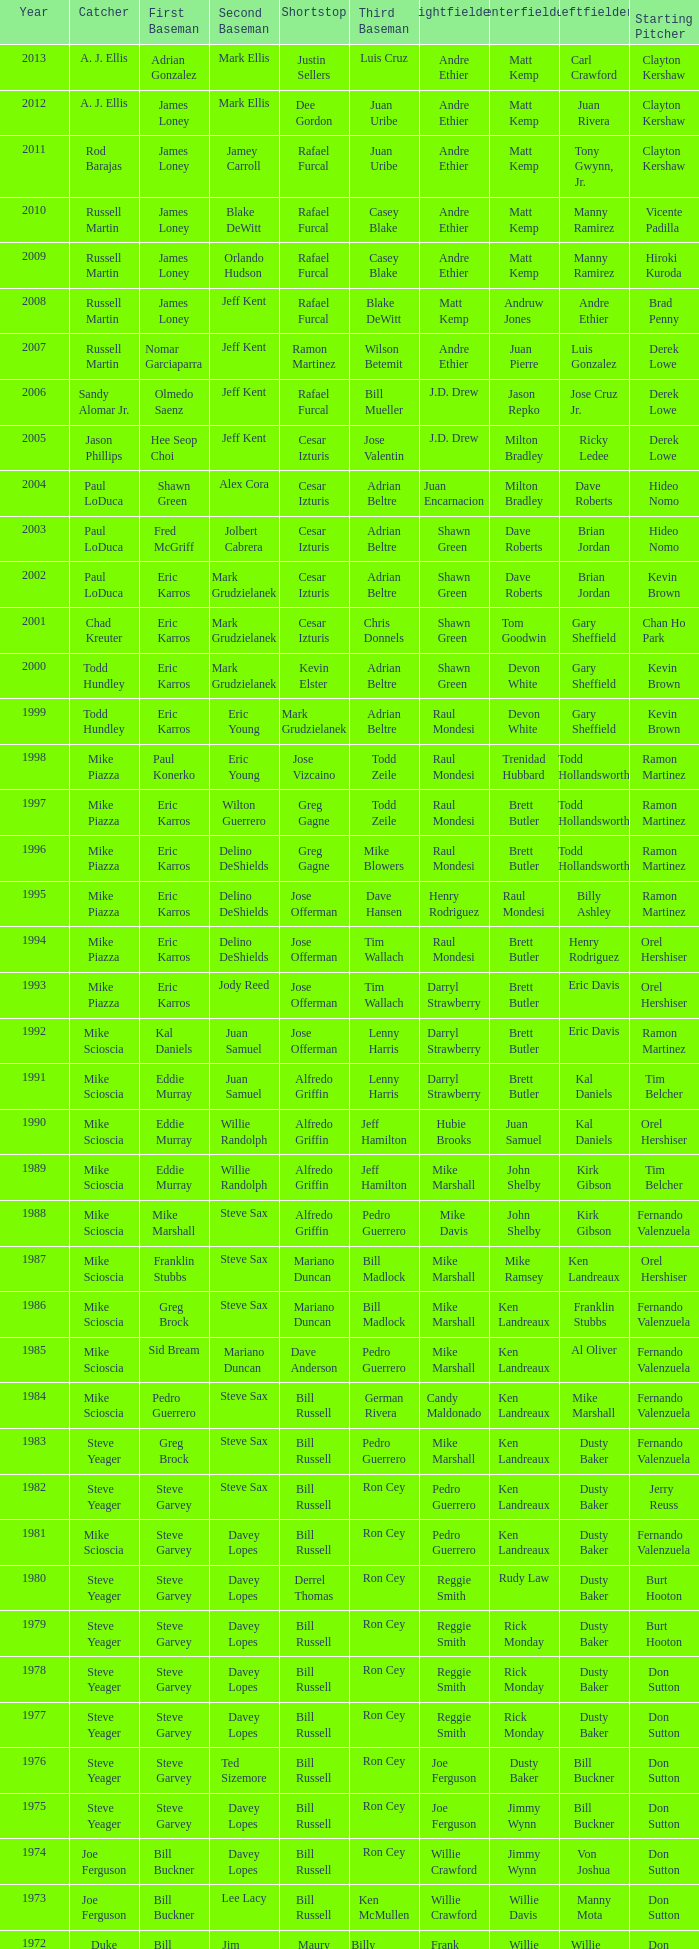Who occupied the shortstop role when jim lefebvre was at 2nd base, willie davis at center field, and don drysdale as the starting pitcher? Maury Wills. 